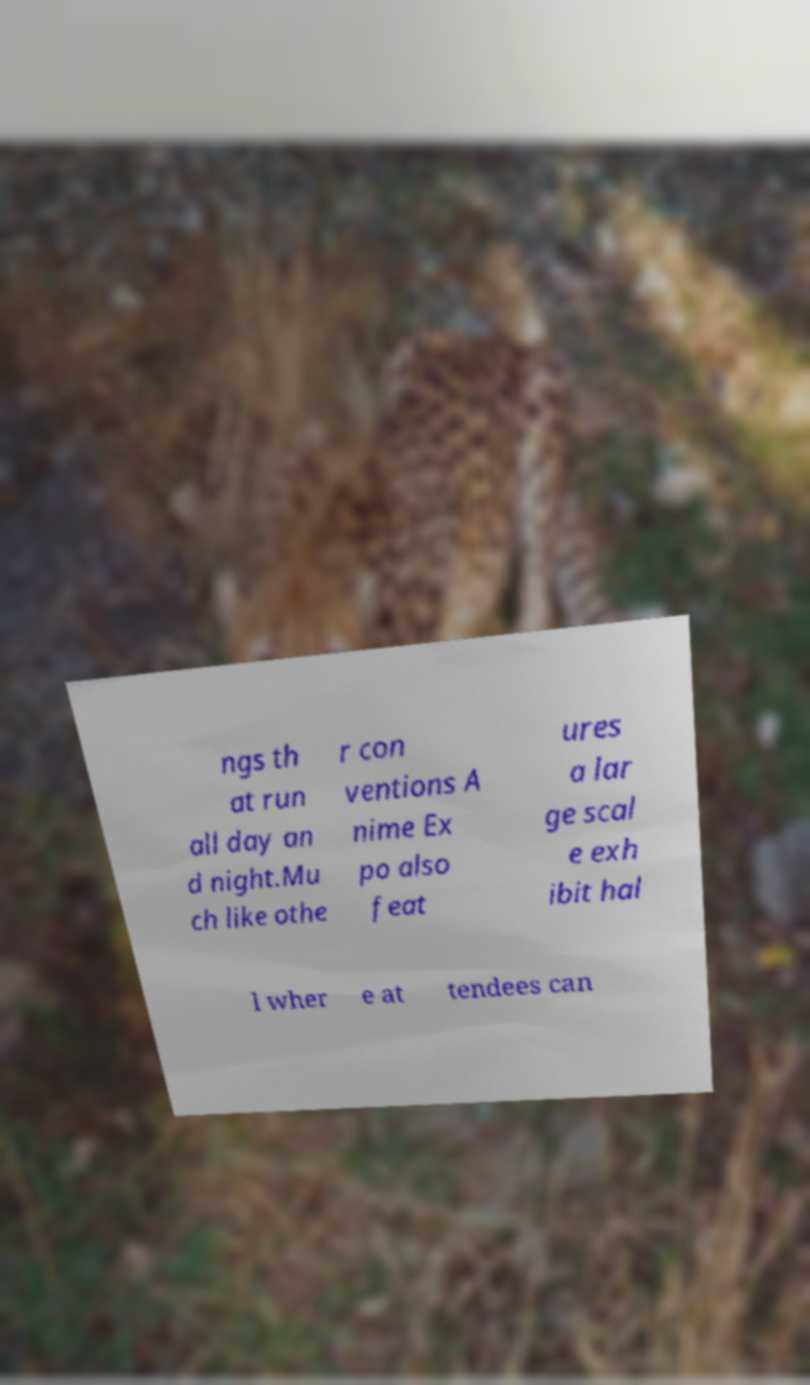There's text embedded in this image that I need extracted. Can you transcribe it verbatim? ngs th at run all day an d night.Mu ch like othe r con ventions A nime Ex po also feat ures a lar ge scal e exh ibit hal l wher e at tendees can 